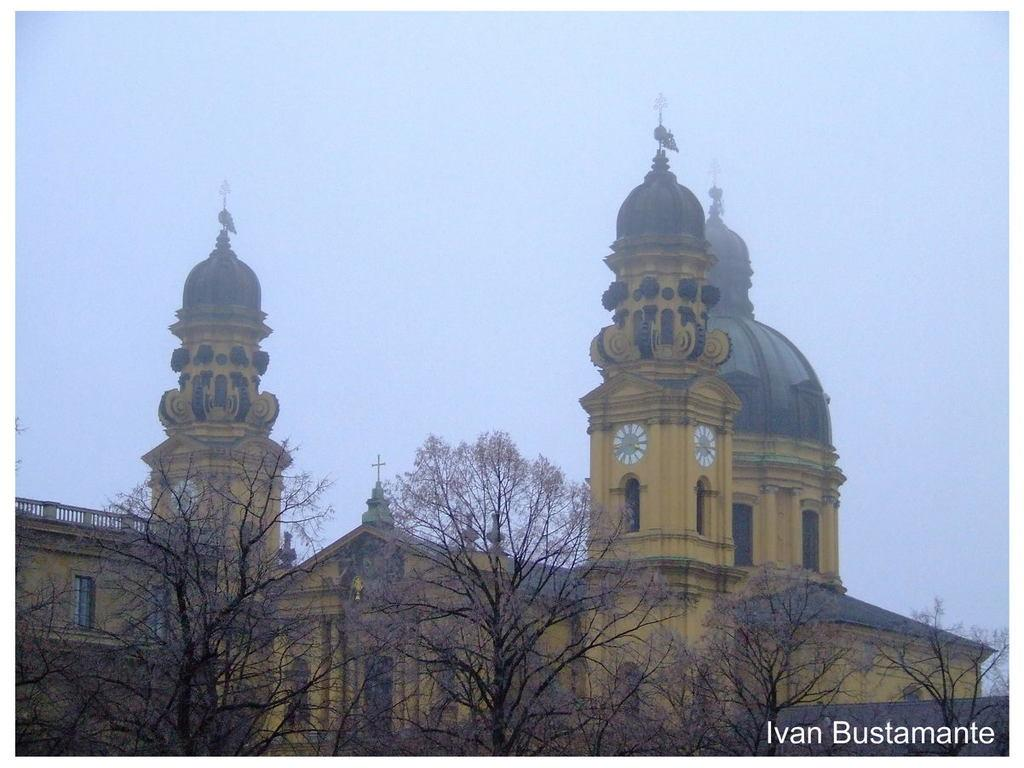What is the main subject in the center of the image? There is a building in the center of the image. What type of vegetation can be seen at the bottom of the image? Trees are visible at the bottom of the image. What part of the natural environment is visible in the background of the image? The sky is visible in the background of the image. Can you tell me how many apples are hanging from the trees in the image? There are no apples visible in the image; only trees are present. Is there a girl in the image showing off her new toy? There is no girl or toy present in the image; it features a building, trees, and the sky. 